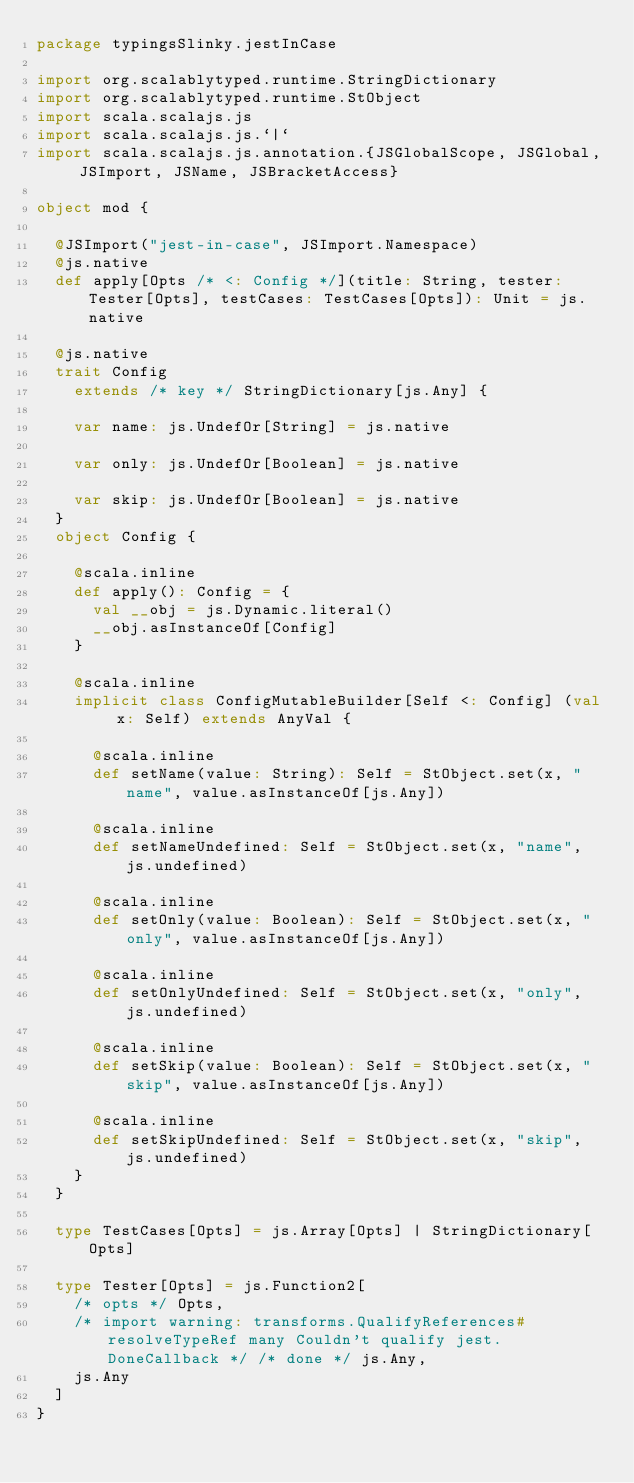<code> <loc_0><loc_0><loc_500><loc_500><_Scala_>package typingsSlinky.jestInCase

import org.scalablytyped.runtime.StringDictionary
import org.scalablytyped.runtime.StObject
import scala.scalajs.js
import scala.scalajs.js.`|`
import scala.scalajs.js.annotation.{JSGlobalScope, JSGlobal, JSImport, JSName, JSBracketAccess}

object mod {
  
  @JSImport("jest-in-case", JSImport.Namespace)
  @js.native
  def apply[Opts /* <: Config */](title: String, tester: Tester[Opts], testCases: TestCases[Opts]): Unit = js.native
  
  @js.native
  trait Config
    extends /* key */ StringDictionary[js.Any] {
    
    var name: js.UndefOr[String] = js.native
    
    var only: js.UndefOr[Boolean] = js.native
    
    var skip: js.UndefOr[Boolean] = js.native
  }
  object Config {
    
    @scala.inline
    def apply(): Config = {
      val __obj = js.Dynamic.literal()
      __obj.asInstanceOf[Config]
    }
    
    @scala.inline
    implicit class ConfigMutableBuilder[Self <: Config] (val x: Self) extends AnyVal {
      
      @scala.inline
      def setName(value: String): Self = StObject.set(x, "name", value.asInstanceOf[js.Any])
      
      @scala.inline
      def setNameUndefined: Self = StObject.set(x, "name", js.undefined)
      
      @scala.inline
      def setOnly(value: Boolean): Self = StObject.set(x, "only", value.asInstanceOf[js.Any])
      
      @scala.inline
      def setOnlyUndefined: Self = StObject.set(x, "only", js.undefined)
      
      @scala.inline
      def setSkip(value: Boolean): Self = StObject.set(x, "skip", value.asInstanceOf[js.Any])
      
      @scala.inline
      def setSkipUndefined: Self = StObject.set(x, "skip", js.undefined)
    }
  }
  
  type TestCases[Opts] = js.Array[Opts] | StringDictionary[Opts]
  
  type Tester[Opts] = js.Function2[
    /* opts */ Opts, 
    /* import warning: transforms.QualifyReferences#resolveTypeRef many Couldn't qualify jest.DoneCallback */ /* done */ js.Any, 
    js.Any
  ]
}
</code> 